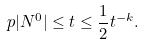Convert formula to latex. <formula><loc_0><loc_0><loc_500><loc_500>\ p { | N ^ { 0 } | \leq t } \leq \frac { 1 } { 2 } t ^ { - k } .</formula> 